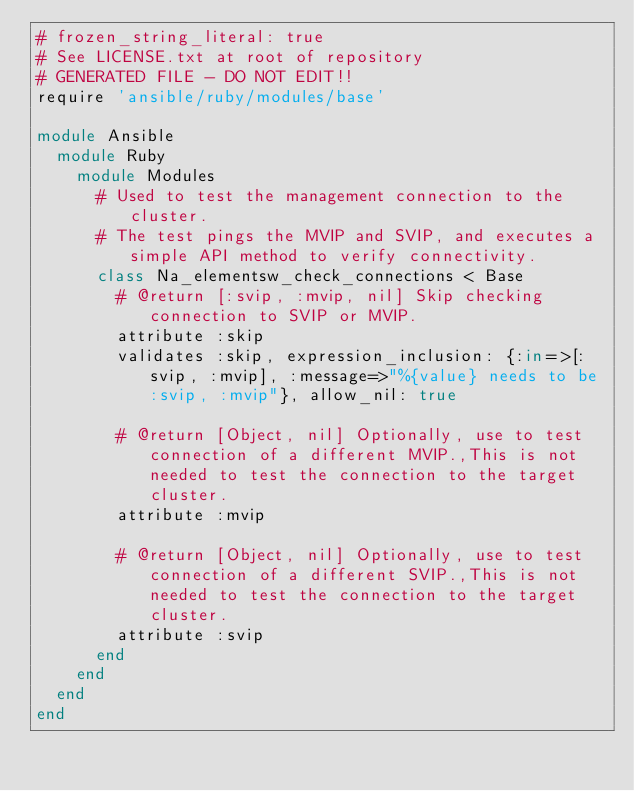Convert code to text. <code><loc_0><loc_0><loc_500><loc_500><_Ruby_># frozen_string_literal: true
# See LICENSE.txt at root of repository
# GENERATED FILE - DO NOT EDIT!!
require 'ansible/ruby/modules/base'

module Ansible
  module Ruby
    module Modules
      # Used to test the management connection to the cluster.
      # The test pings the MVIP and SVIP, and executes a simple API method to verify connectivity.
      class Na_elementsw_check_connections < Base
        # @return [:svip, :mvip, nil] Skip checking connection to SVIP or MVIP.
        attribute :skip
        validates :skip, expression_inclusion: {:in=>[:svip, :mvip], :message=>"%{value} needs to be :svip, :mvip"}, allow_nil: true

        # @return [Object, nil] Optionally, use to test connection of a different MVIP.,This is not needed to test the connection to the target cluster.
        attribute :mvip

        # @return [Object, nil] Optionally, use to test connection of a different SVIP.,This is not needed to test the connection to the target cluster.
        attribute :svip
      end
    end
  end
end
</code> 